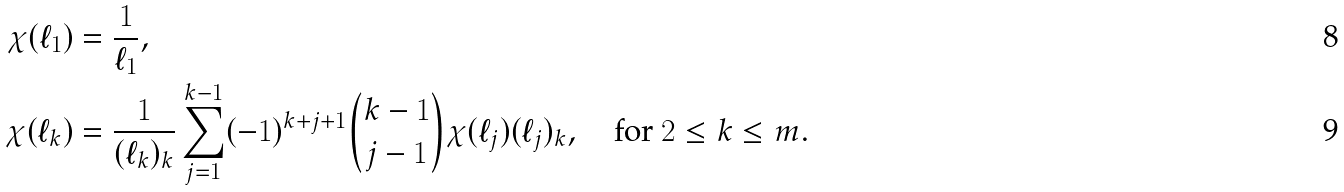Convert formula to latex. <formula><loc_0><loc_0><loc_500><loc_500>\chi ( \ell _ { 1 } ) & = \frac { 1 } { \ell _ { 1 } } , \\ \chi ( \ell _ { k } ) & = \frac { 1 } { ( \ell _ { k } ) _ { k } } \sum _ { j = 1 } ^ { k - 1 } ( - 1 ) ^ { k + j + 1 } \binom { k - 1 } { j - 1 } \chi ( \ell _ { j } ) ( \ell _ { j } ) _ { k } , \quad \text {for $2\leq k\leq m$.}</formula> 